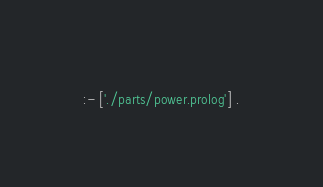Convert code to text. <code><loc_0><loc_0><loc_500><loc_500><_Prolog_>
:- ['./parts/power.prolog'] .
</code> 